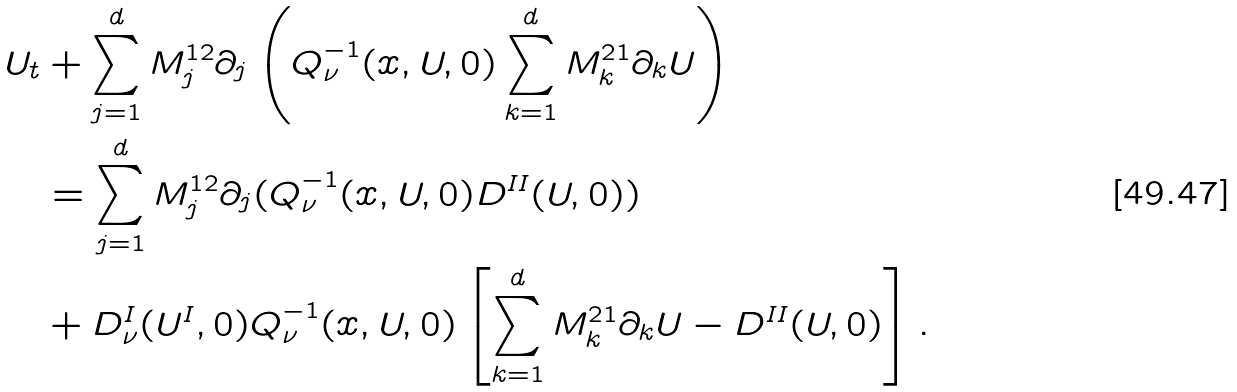<formula> <loc_0><loc_0><loc_500><loc_500>U _ { t } & + \sum _ { j = 1 } ^ { d } M ^ { 1 2 } _ { j } \partial _ { j } \left ( Q _ { \nu } ^ { - 1 } ( x , U , 0 ) \sum _ { k = 1 } ^ { d } M ^ { 2 1 } _ { k } \partial _ { k } U \right ) \\ & = \sum _ { j = 1 } ^ { d } M ^ { 1 2 } _ { j } \partial _ { j } ( Q _ { \nu } ^ { - 1 } ( x , U , 0 ) D ^ { I I } ( U , 0 ) ) \\ & + D ^ { I } _ { \nu } ( U ^ { I } , 0 ) Q _ { \nu } ^ { - 1 } ( x , U , 0 ) \left [ \sum _ { k = 1 } ^ { d } M ^ { 2 1 } _ { k } \partial _ { k } U - D ^ { I I } ( U , 0 ) \right ] .</formula> 